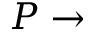Convert formula to latex. <formula><loc_0><loc_0><loc_500><loc_500>P \rightarrow</formula> 